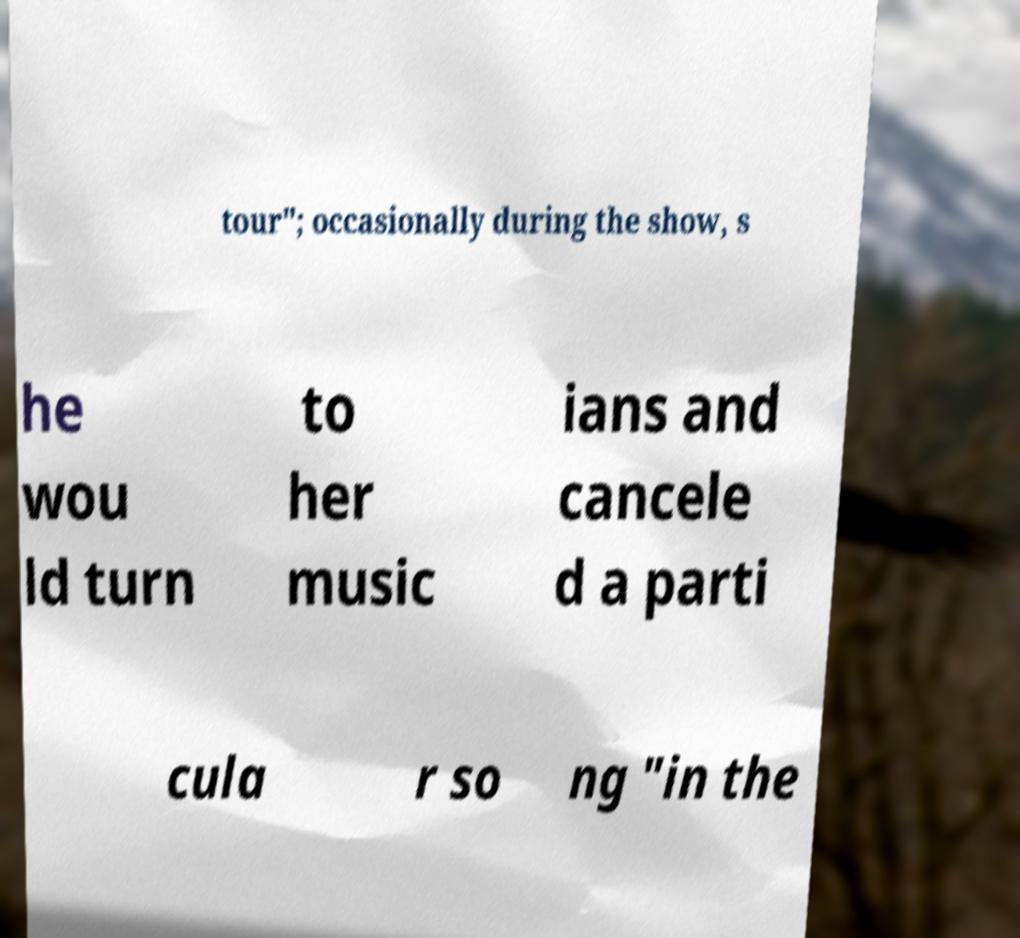Could you extract and type out the text from this image? tour"; occasionally during the show, s he wou ld turn to her music ians and cancele d a parti cula r so ng "in the 